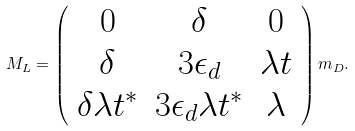Convert formula to latex. <formula><loc_0><loc_0><loc_500><loc_500>M _ { L } = \left ( \begin{array} { c c c } 0 & \delta & 0 \\ \delta & 3 \epsilon _ { d } & \lambda t \\ \delta \lambda t ^ { * } & 3 \epsilon _ { d } \lambda t ^ { * } & \lambda \end{array} \right ) m _ { D } .</formula> 